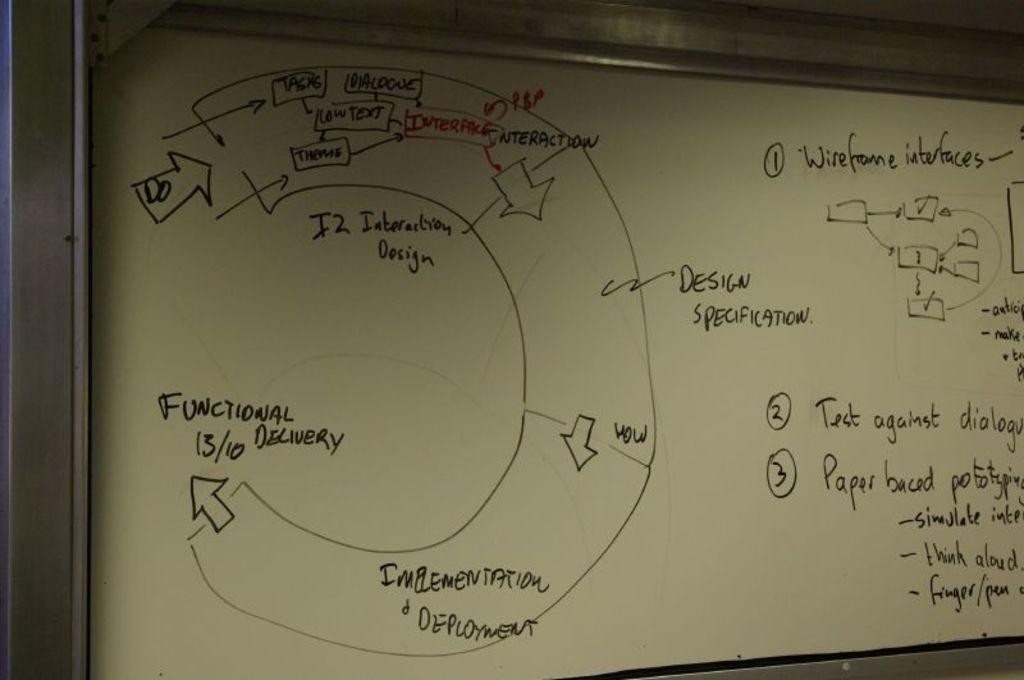<image>
Provide a brief description of the given image. A diagram with arrows that end with "functional delivery." 